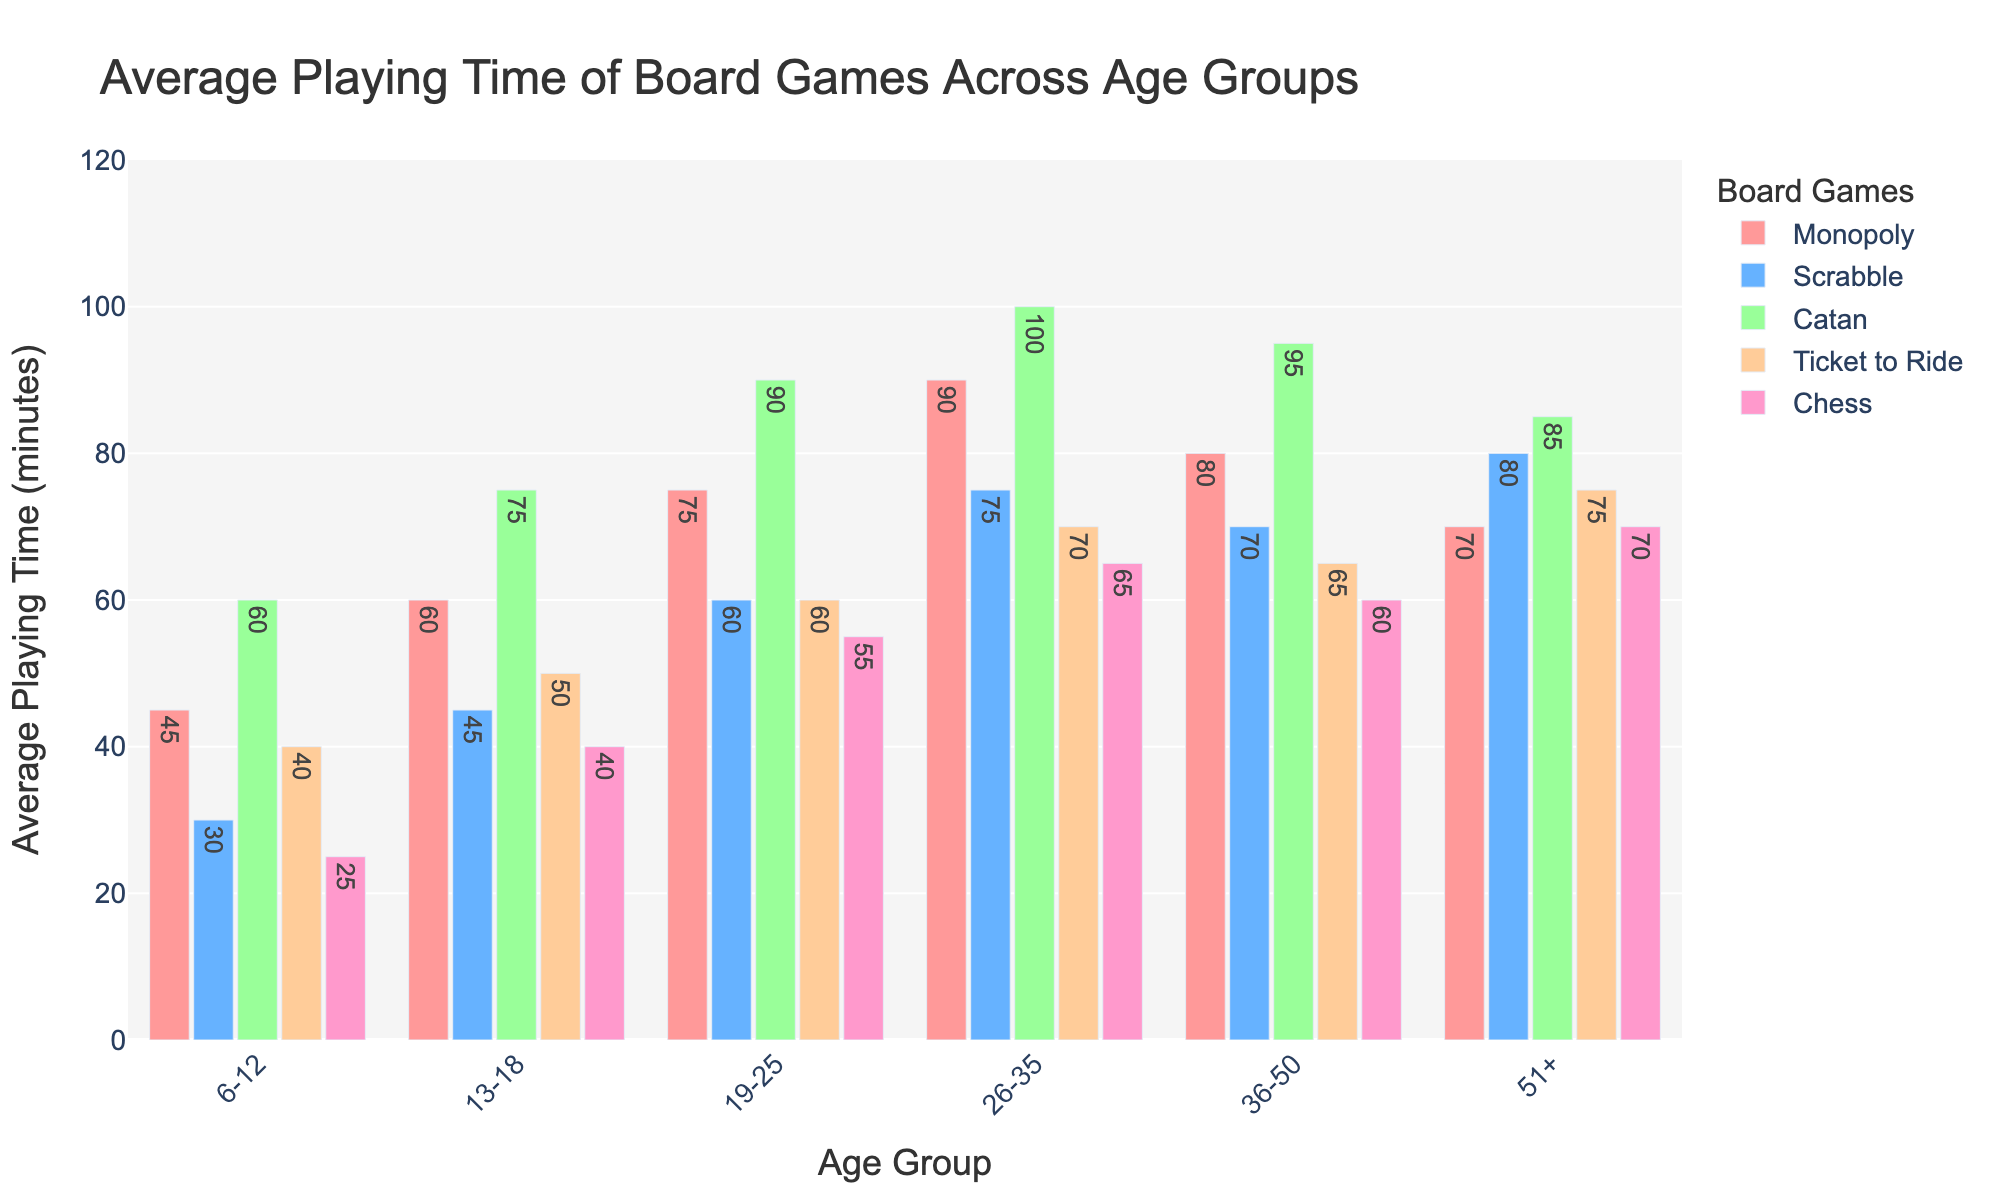What is the average playing time of Catan for age group 19-25? Look at the bar corresponding to "Catan" for the age group "19-25" and read the value. The bar shows 90 minutes.
Answer: 90 minutes Which board game has the shortest average playing time for age group 26-35? Compare the heights of all the bars for the age group "26-35". The shortest bar corresponds to "Chess", which shows 65 minutes.
Answer: Chess By how many minutes does the average playing time of Scrabble for the age group 13-18 exceed that for the age group 6-12? Check the values for Scrabble in the age groups "13-18" and "6-12". The values are 45 and 30 minutes respectively. The difference is 45 - 30 = 15 minutes.
Answer: 15 minutes Which age group has the longest average playing time for Chess? Compare the heights of the bars for "Chess" across different age groups. The bar for the age group "51+" is the tallest, showing 70 minutes.
Answer: 51+ How does the average playing time for Ticket to Ride change as age increases from 6-12 to 19-25? List the values for each age group in this range. Check the values for "Ticket to Ride" in the age groups "6-12", "13-18", and "19-25". The values are 40, 50, and 60 minutes respectively. Moving from 6-12 to 19-25, the average playing time increases incrementally.
Answer: 40, 50, 60 minutes What is the total average playing time of all board games for the age group 36-50? Sum the values of all board games for the age group "36-50". The values are Monopoly (80), Scrabble (70), Catan (95), Ticket to Ride (65), and Chess (60). Total = 80 + 70 + 95 + 65 + 60 = 370 minutes.
Answer: 370 minutes Which age group has the highest average playing time for Monopoly and what is the time? Compare the heights of the bars for "Monopoly" across different age groups. The tallest bar is for the age group "26-35", showing 90 minutes.
Answer: 26-35, 90 minutes 